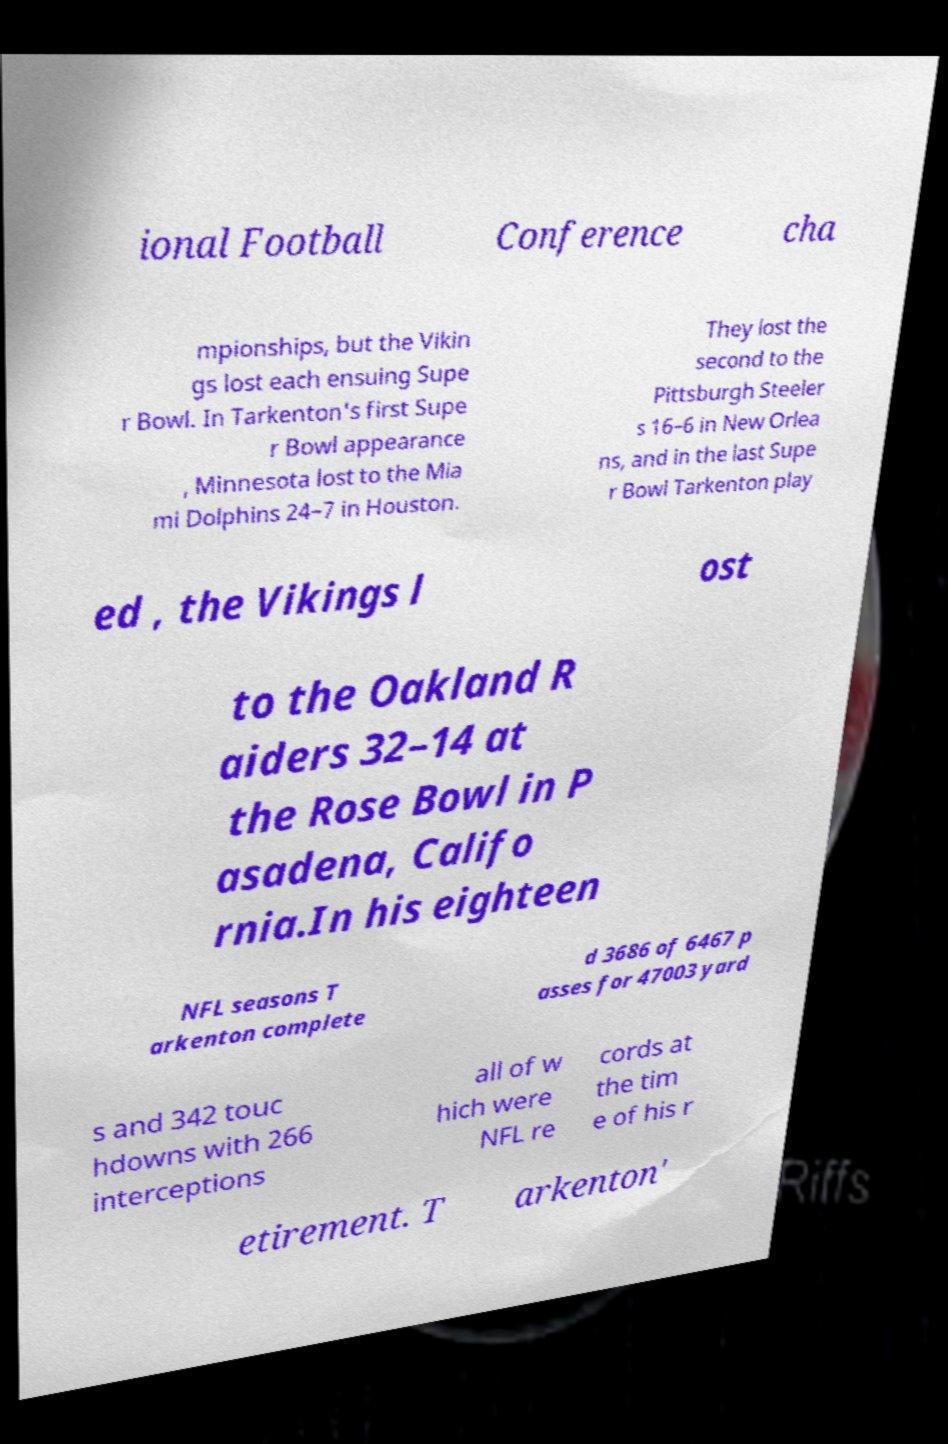Can you accurately transcribe the text from the provided image for me? ional Football Conference cha mpionships, but the Vikin gs lost each ensuing Supe r Bowl. In Tarkenton's first Supe r Bowl appearance , Minnesota lost to the Mia mi Dolphins 24–7 in Houston. They lost the second to the Pittsburgh Steeler s 16–6 in New Orlea ns, and in the last Supe r Bowl Tarkenton play ed , the Vikings l ost to the Oakland R aiders 32–14 at the Rose Bowl in P asadena, Califo rnia.In his eighteen NFL seasons T arkenton complete d 3686 of 6467 p asses for 47003 yard s and 342 touc hdowns with 266 interceptions all of w hich were NFL re cords at the tim e of his r etirement. T arkenton' 